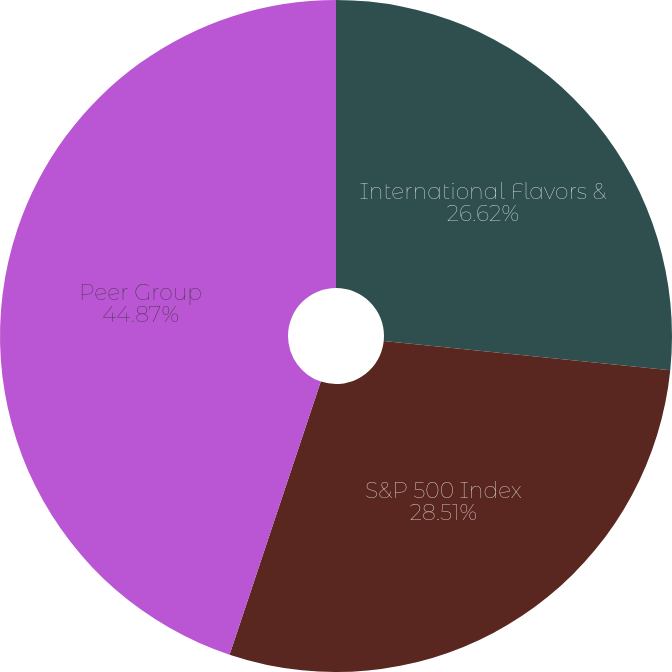Convert chart. <chart><loc_0><loc_0><loc_500><loc_500><pie_chart><fcel>International Flavors &<fcel>S&P 500 Index<fcel>Peer Group<nl><fcel>26.62%<fcel>28.51%<fcel>44.87%<nl></chart> 